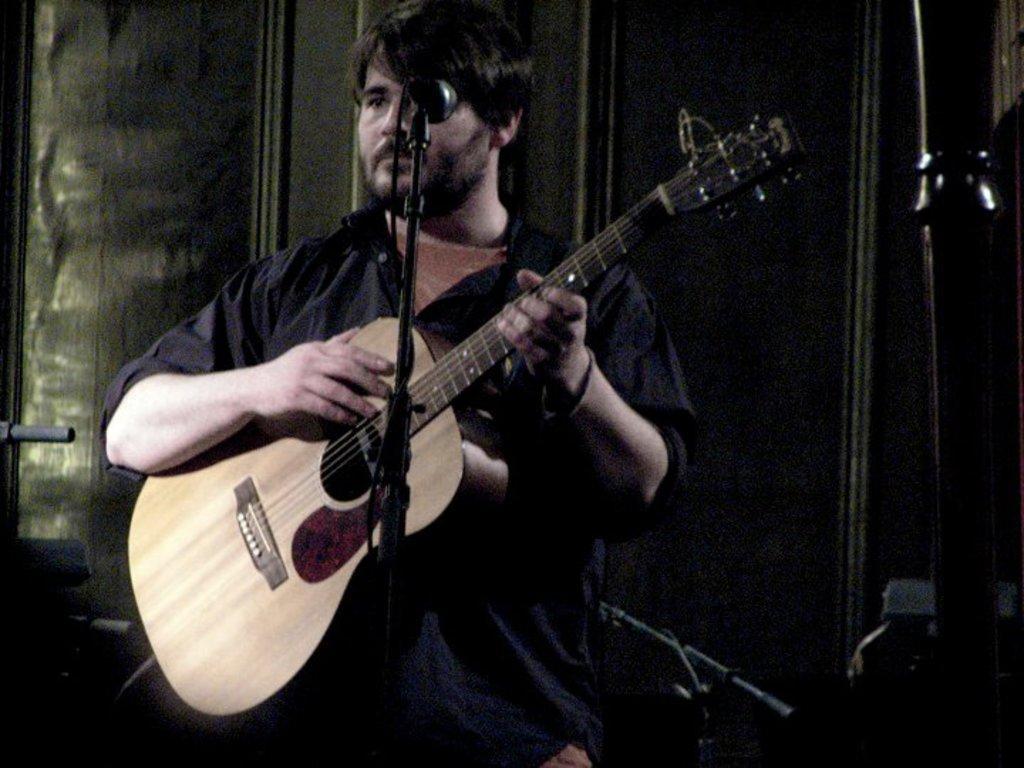In one or two sentences, can you explain what this image depicts? This picture shows a man holding a guitar in his hands we see a microphone in front of him. 